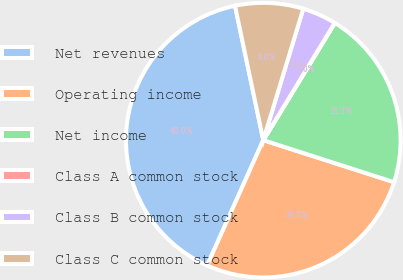Convert chart. <chart><loc_0><loc_0><loc_500><loc_500><pie_chart><fcel>Net revenues<fcel>Operating income<fcel>Net income<fcel>Class A common stock<fcel>Class B common stock<fcel>Class C common stock<nl><fcel>39.99%<fcel>26.76%<fcel>21.23%<fcel>0.01%<fcel>4.01%<fcel>8.0%<nl></chart> 